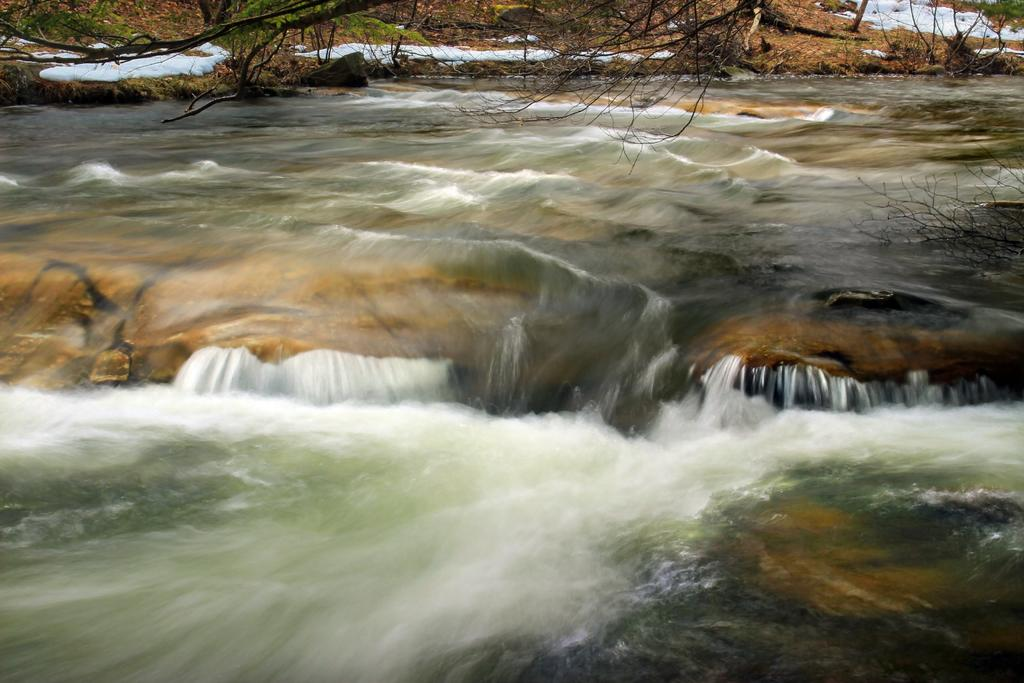What is visible in the image? Water is visible in the image. What can be seen in the background of the image? There are trees and snow on the ground in the background of the image. What type of error can be seen in the image? There is no error present in the image. What kind of hospital is visible in the image? There is no hospital present in the image. 